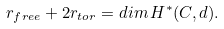<formula> <loc_0><loc_0><loc_500><loc_500>r _ { f r e e } + 2 r _ { t o r } = d i m \, H ^ { * } ( C , d ) .</formula> 